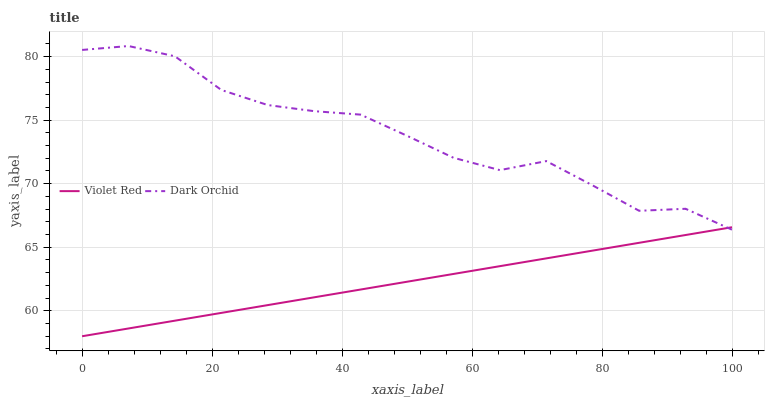Does Violet Red have the minimum area under the curve?
Answer yes or no. Yes. Does Dark Orchid have the maximum area under the curve?
Answer yes or no. Yes. Does Dark Orchid have the minimum area under the curve?
Answer yes or no. No. Is Violet Red the smoothest?
Answer yes or no. Yes. Is Dark Orchid the roughest?
Answer yes or no. Yes. Is Dark Orchid the smoothest?
Answer yes or no. No. Does Dark Orchid have the lowest value?
Answer yes or no. No. Does Dark Orchid have the highest value?
Answer yes or no. Yes. Does Violet Red intersect Dark Orchid?
Answer yes or no. Yes. Is Violet Red less than Dark Orchid?
Answer yes or no. No. Is Violet Red greater than Dark Orchid?
Answer yes or no. No. 